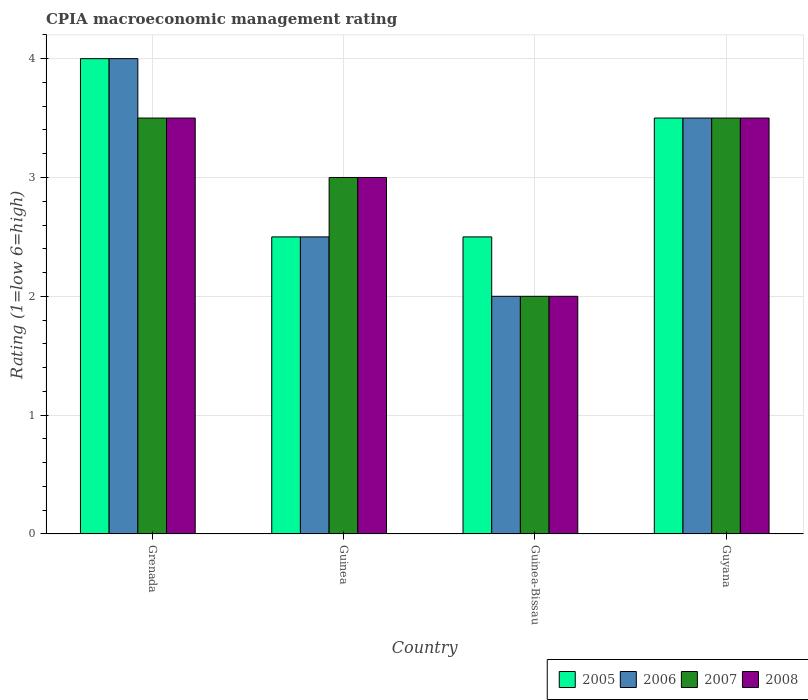How many groups of bars are there?
Your response must be concise. 4. Are the number of bars on each tick of the X-axis equal?
Your response must be concise. Yes. How many bars are there on the 1st tick from the right?
Your response must be concise. 4. What is the label of the 2nd group of bars from the left?
Keep it short and to the point. Guinea. Across all countries, what is the minimum CPIA rating in 2005?
Give a very brief answer. 2.5. In which country was the CPIA rating in 2005 maximum?
Ensure brevity in your answer.  Grenada. In which country was the CPIA rating in 2008 minimum?
Keep it short and to the point. Guinea-Bissau. What is the average CPIA rating in 2005 per country?
Ensure brevity in your answer.  3.12. What is the difference between the CPIA rating of/in 2007 and CPIA rating of/in 2006 in Guinea-Bissau?
Your response must be concise. 0. What is the ratio of the CPIA rating in 2006 in Guinea to that in Guinea-Bissau?
Your answer should be very brief. 1.25. Is the CPIA rating in 2007 in Grenada less than that in Guyana?
Make the answer very short. No. What is the difference between the highest and the lowest CPIA rating in 2008?
Keep it short and to the point. 1.5. Are all the bars in the graph horizontal?
Ensure brevity in your answer.  No. How many countries are there in the graph?
Offer a very short reply. 4. What is the difference between two consecutive major ticks on the Y-axis?
Give a very brief answer. 1. Where does the legend appear in the graph?
Ensure brevity in your answer.  Bottom right. How many legend labels are there?
Offer a very short reply. 4. How are the legend labels stacked?
Offer a very short reply. Horizontal. What is the title of the graph?
Provide a succinct answer. CPIA macroeconomic management rating. What is the label or title of the Y-axis?
Give a very brief answer. Rating (1=low 6=high). What is the Rating (1=low 6=high) of 2006 in Grenada?
Offer a very short reply. 4. What is the Rating (1=low 6=high) in 2006 in Guinea?
Keep it short and to the point. 2.5. What is the Rating (1=low 6=high) in 2008 in Guinea?
Keep it short and to the point. 3. What is the Rating (1=low 6=high) of 2005 in Guinea-Bissau?
Your response must be concise. 2.5. What is the Rating (1=low 6=high) in 2006 in Guinea-Bissau?
Provide a short and direct response. 2. What is the Rating (1=low 6=high) in 2008 in Guinea-Bissau?
Provide a succinct answer. 2. What is the Rating (1=low 6=high) in 2005 in Guyana?
Offer a very short reply. 3.5. What is the Rating (1=low 6=high) in 2006 in Guyana?
Keep it short and to the point. 3.5. What is the Rating (1=low 6=high) in 2008 in Guyana?
Your answer should be compact. 3.5. Across all countries, what is the maximum Rating (1=low 6=high) in 2005?
Provide a succinct answer. 4. Across all countries, what is the maximum Rating (1=low 6=high) of 2006?
Your answer should be very brief. 4. Across all countries, what is the maximum Rating (1=low 6=high) of 2007?
Your response must be concise. 3.5. Across all countries, what is the maximum Rating (1=low 6=high) in 2008?
Your response must be concise. 3.5. Across all countries, what is the minimum Rating (1=low 6=high) in 2005?
Provide a short and direct response. 2.5. Across all countries, what is the minimum Rating (1=low 6=high) of 2008?
Give a very brief answer. 2. What is the total Rating (1=low 6=high) in 2007 in the graph?
Provide a short and direct response. 12. What is the total Rating (1=low 6=high) of 2008 in the graph?
Make the answer very short. 12. What is the difference between the Rating (1=low 6=high) in 2005 in Grenada and that in Guinea?
Your answer should be compact. 1.5. What is the difference between the Rating (1=low 6=high) in 2008 in Grenada and that in Guinea?
Give a very brief answer. 0.5. What is the difference between the Rating (1=low 6=high) of 2007 in Grenada and that in Guinea-Bissau?
Your answer should be very brief. 1.5. What is the difference between the Rating (1=low 6=high) of 2008 in Grenada and that in Guinea-Bissau?
Your answer should be compact. 1.5. What is the difference between the Rating (1=low 6=high) in 2006 in Grenada and that in Guyana?
Make the answer very short. 0.5. What is the difference between the Rating (1=low 6=high) of 2007 in Grenada and that in Guyana?
Your response must be concise. 0. What is the difference between the Rating (1=low 6=high) in 2008 in Grenada and that in Guyana?
Your answer should be very brief. 0. What is the difference between the Rating (1=low 6=high) in 2005 in Guinea and that in Guyana?
Your answer should be very brief. -1. What is the difference between the Rating (1=low 6=high) in 2006 in Guinea and that in Guyana?
Keep it short and to the point. -1. What is the difference between the Rating (1=low 6=high) in 2008 in Guinea and that in Guyana?
Make the answer very short. -0.5. What is the difference between the Rating (1=low 6=high) of 2007 in Guinea-Bissau and that in Guyana?
Your response must be concise. -1.5. What is the difference between the Rating (1=low 6=high) in 2008 in Guinea-Bissau and that in Guyana?
Your answer should be compact. -1.5. What is the difference between the Rating (1=low 6=high) in 2005 in Grenada and the Rating (1=low 6=high) in 2006 in Guinea?
Offer a very short reply. 1.5. What is the difference between the Rating (1=low 6=high) in 2005 in Grenada and the Rating (1=low 6=high) in 2008 in Guinea?
Your answer should be compact. 1. What is the difference between the Rating (1=low 6=high) of 2007 in Grenada and the Rating (1=low 6=high) of 2008 in Guinea?
Your answer should be compact. 0.5. What is the difference between the Rating (1=low 6=high) in 2006 in Grenada and the Rating (1=low 6=high) in 2007 in Guinea-Bissau?
Make the answer very short. 2. What is the difference between the Rating (1=low 6=high) of 2007 in Grenada and the Rating (1=low 6=high) of 2008 in Guinea-Bissau?
Offer a very short reply. 1.5. What is the difference between the Rating (1=low 6=high) of 2005 in Grenada and the Rating (1=low 6=high) of 2006 in Guyana?
Provide a short and direct response. 0.5. What is the difference between the Rating (1=low 6=high) of 2005 in Grenada and the Rating (1=low 6=high) of 2007 in Guyana?
Your response must be concise. 0.5. What is the difference between the Rating (1=low 6=high) of 2005 in Grenada and the Rating (1=low 6=high) of 2008 in Guyana?
Make the answer very short. 0.5. What is the difference between the Rating (1=low 6=high) of 2006 in Grenada and the Rating (1=low 6=high) of 2007 in Guyana?
Give a very brief answer. 0.5. What is the difference between the Rating (1=low 6=high) of 2007 in Grenada and the Rating (1=low 6=high) of 2008 in Guyana?
Offer a very short reply. 0. What is the difference between the Rating (1=low 6=high) in 2005 in Guinea and the Rating (1=low 6=high) in 2007 in Guinea-Bissau?
Make the answer very short. 0.5. What is the difference between the Rating (1=low 6=high) in 2005 in Guinea and the Rating (1=low 6=high) in 2008 in Guinea-Bissau?
Offer a terse response. 0.5. What is the difference between the Rating (1=low 6=high) in 2006 in Guinea and the Rating (1=low 6=high) in 2008 in Guinea-Bissau?
Provide a succinct answer. 0.5. What is the difference between the Rating (1=low 6=high) in 2007 in Guinea and the Rating (1=low 6=high) in 2008 in Guinea-Bissau?
Offer a terse response. 1. What is the difference between the Rating (1=low 6=high) of 2005 in Guinea and the Rating (1=low 6=high) of 2007 in Guyana?
Your answer should be very brief. -1. What is the difference between the Rating (1=low 6=high) in 2005 in Guinea and the Rating (1=low 6=high) in 2008 in Guyana?
Your answer should be very brief. -1. What is the difference between the Rating (1=low 6=high) of 2006 in Guinea and the Rating (1=low 6=high) of 2008 in Guyana?
Offer a very short reply. -1. What is the difference between the Rating (1=low 6=high) of 2005 in Guinea-Bissau and the Rating (1=low 6=high) of 2007 in Guyana?
Keep it short and to the point. -1. What is the difference between the Rating (1=low 6=high) in 2005 in Guinea-Bissau and the Rating (1=low 6=high) in 2008 in Guyana?
Your answer should be compact. -1. What is the average Rating (1=low 6=high) in 2005 per country?
Your response must be concise. 3.12. What is the average Rating (1=low 6=high) of 2006 per country?
Keep it short and to the point. 3. What is the average Rating (1=low 6=high) in 2007 per country?
Keep it short and to the point. 3. What is the difference between the Rating (1=low 6=high) of 2006 and Rating (1=low 6=high) of 2007 in Grenada?
Ensure brevity in your answer.  0.5. What is the difference between the Rating (1=low 6=high) in 2005 and Rating (1=low 6=high) in 2007 in Guinea?
Ensure brevity in your answer.  -0.5. What is the difference between the Rating (1=low 6=high) in 2005 and Rating (1=low 6=high) in 2008 in Guinea?
Your answer should be very brief. -0.5. What is the difference between the Rating (1=low 6=high) in 2007 and Rating (1=low 6=high) in 2008 in Guinea?
Provide a short and direct response. 0. What is the difference between the Rating (1=low 6=high) in 2006 and Rating (1=low 6=high) in 2007 in Guinea-Bissau?
Your response must be concise. 0. What is the difference between the Rating (1=low 6=high) of 2005 and Rating (1=low 6=high) of 2008 in Guyana?
Offer a very short reply. 0. What is the difference between the Rating (1=low 6=high) of 2006 and Rating (1=low 6=high) of 2007 in Guyana?
Offer a very short reply. 0. What is the difference between the Rating (1=low 6=high) of 2006 and Rating (1=low 6=high) of 2008 in Guyana?
Offer a very short reply. 0. What is the difference between the Rating (1=low 6=high) in 2007 and Rating (1=low 6=high) in 2008 in Guyana?
Provide a succinct answer. 0. What is the ratio of the Rating (1=low 6=high) in 2005 in Grenada to that in Guinea?
Provide a short and direct response. 1.6. What is the ratio of the Rating (1=low 6=high) of 2007 in Grenada to that in Guinea-Bissau?
Provide a succinct answer. 1.75. What is the ratio of the Rating (1=low 6=high) in 2007 in Grenada to that in Guyana?
Your response must be concise. 1. What is the ratio of the Rating (1=low 6=high) in 2006 in Guinea to that in Guinea-Bissau?
Ensure brevity in your answer.  1.25. What is the ratio of the Rating (1=low 6=high) of 2008 in Guinea to that in Guinea-Bissau?
Offer a very short reply. 1.5. What is the ratio of the Rating (1=low 6=high) of 2005 in Guinea to that in Guyana?
Your answer should be compact. 0.71. What is the ratio of the Rating (1=low 6=high) in 2007 in Guinea to that in Guyana?
Provide a short and direct response. 0.86. What is the ratio of the Rating (1=low 6=high) in 2008 in Guinea to that in Guyana?
Provide a succinct answer. 0.86. What is the ratio of the Rating (1=low 6=high) in 2006 in Guinea-Bissau to that in Guyana?
Make the answer very short. 0.57. What is the difference between the highest and the second highest Rating (1=low 6=high) of 2007?
Your response must be concise. 0. What is the difference between the highest and the lowest Rating (1=low 6=high) in 2007?
Offer a terse response. 1.5. What is the difference between the highest and the lowest Rating (1=low 6=high) of 2008?
Keep it short and to the point. 1.5. 